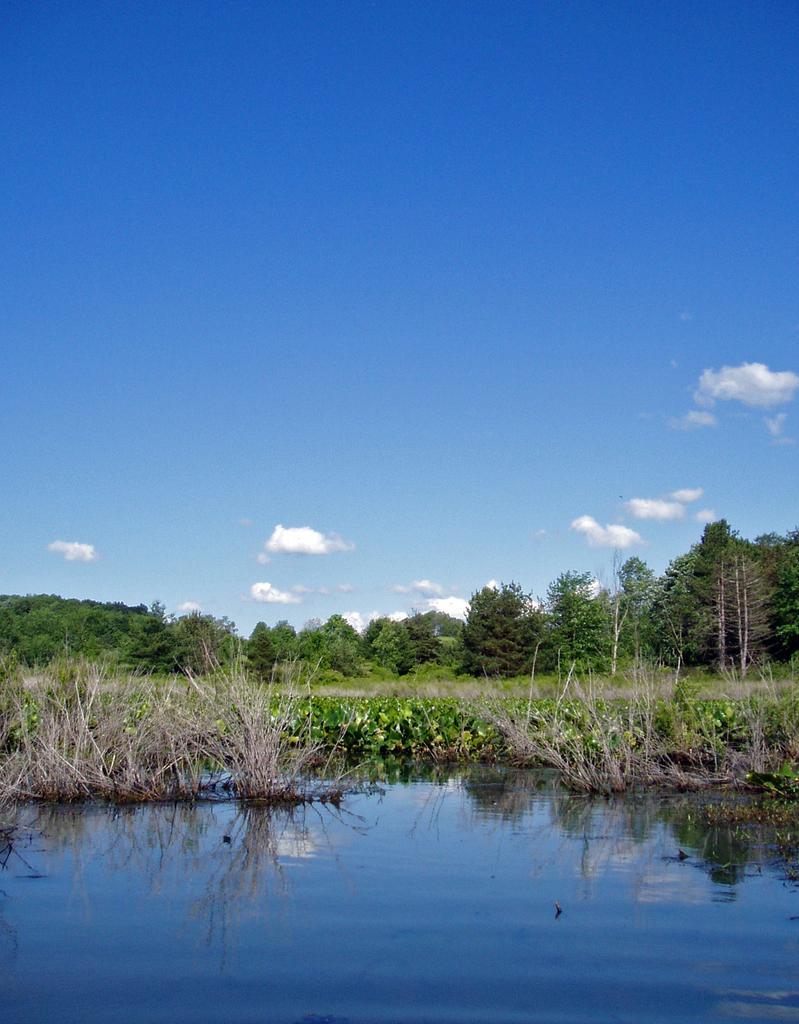Describe this image in one or two sentences. In this image, we can see some trees and plants. There is a lake at the bottom of the image. There is a sky at the top of the image. 